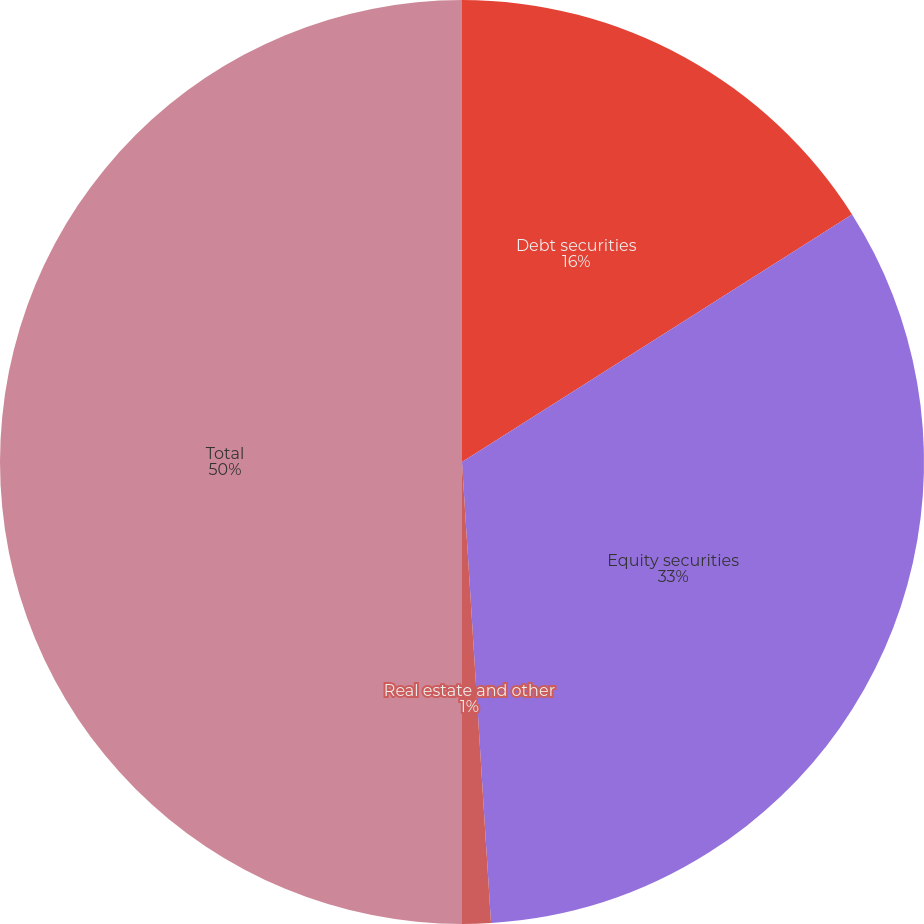Convert chart. <chart><loc_0><loc_0><loc_500><loc_500><pie_chart><fcel>Debt securities<fcel>Equity securities<fcel>Real estate and other<fcel>Total<nl><fcel>16.0%<fcel>33.0%<fcel>1.0%<fcel>50.0%<nl></chart> 